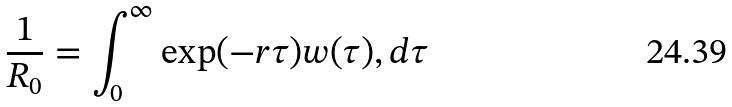<formula> <loc_0><loc_0><loc_500><loc_500>\frac { 1 } { R _ { 0 } } = \int _ { 0 } ^ { \infty } \exp ( - r \tau ) w ( \tau ) , d \tau</formula> 